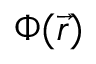<formula> <loc_0><loc_0><loc_500><loc_500>\Phi ( { \vec { r } } )</formula> 